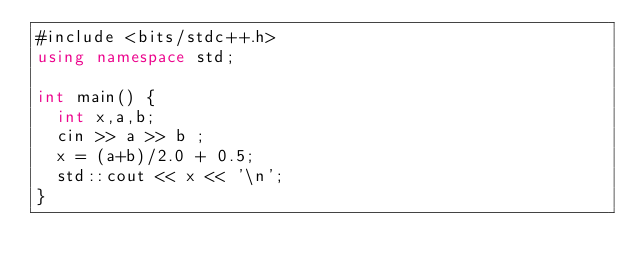Convert code to text. <code><loc_0><loc_0><loc_500><loc_500><_C#_>#include <bits/stdc++.h>
using namespace std;
 
int main() {
  int x,a,b;
  cin >> a >> b ;
  x = (a+b)/2.0 + 0.5;
  std::cout << x << '\n';
}</code> 